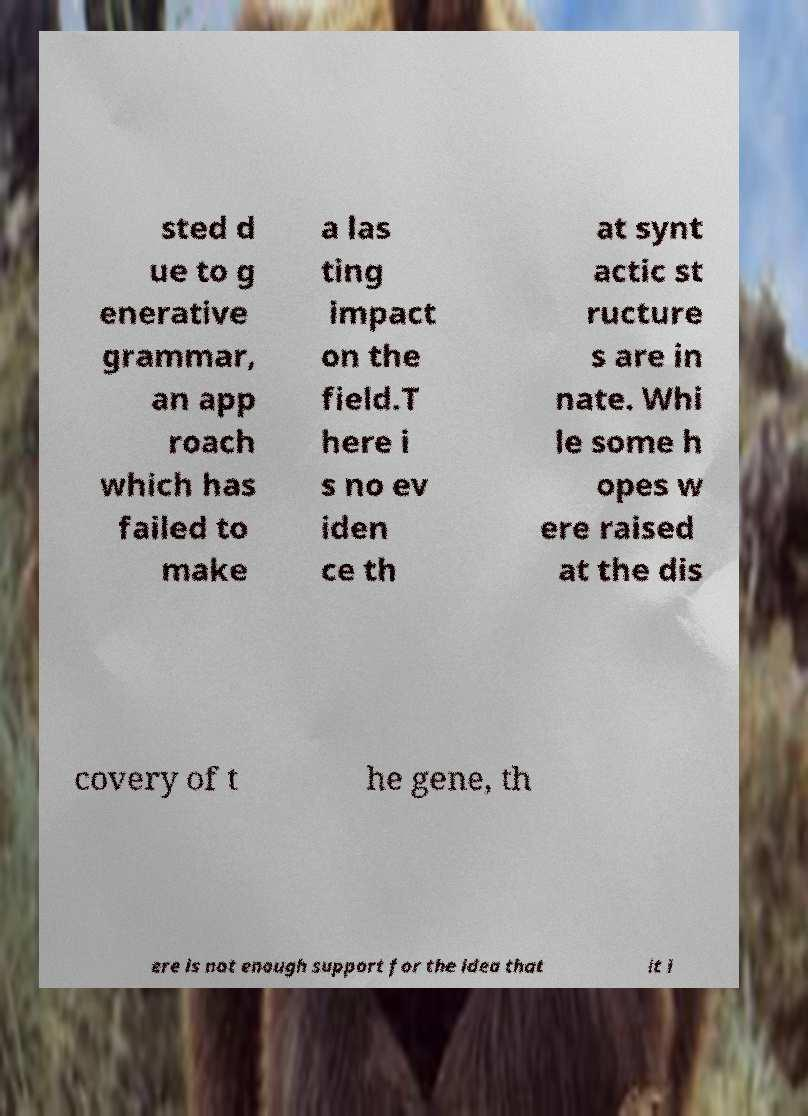Please identify and transcribe the text found in this image. sted d ue to g enerative grammar, an app roach which has failed to make a las ting impact on the field.T here i s no ev iden ce th at synt actic st ructure s are in nate. Whi le some h opes w ere raised at the dis covery of t he gene, th ere is not enough support for the idea that it i 